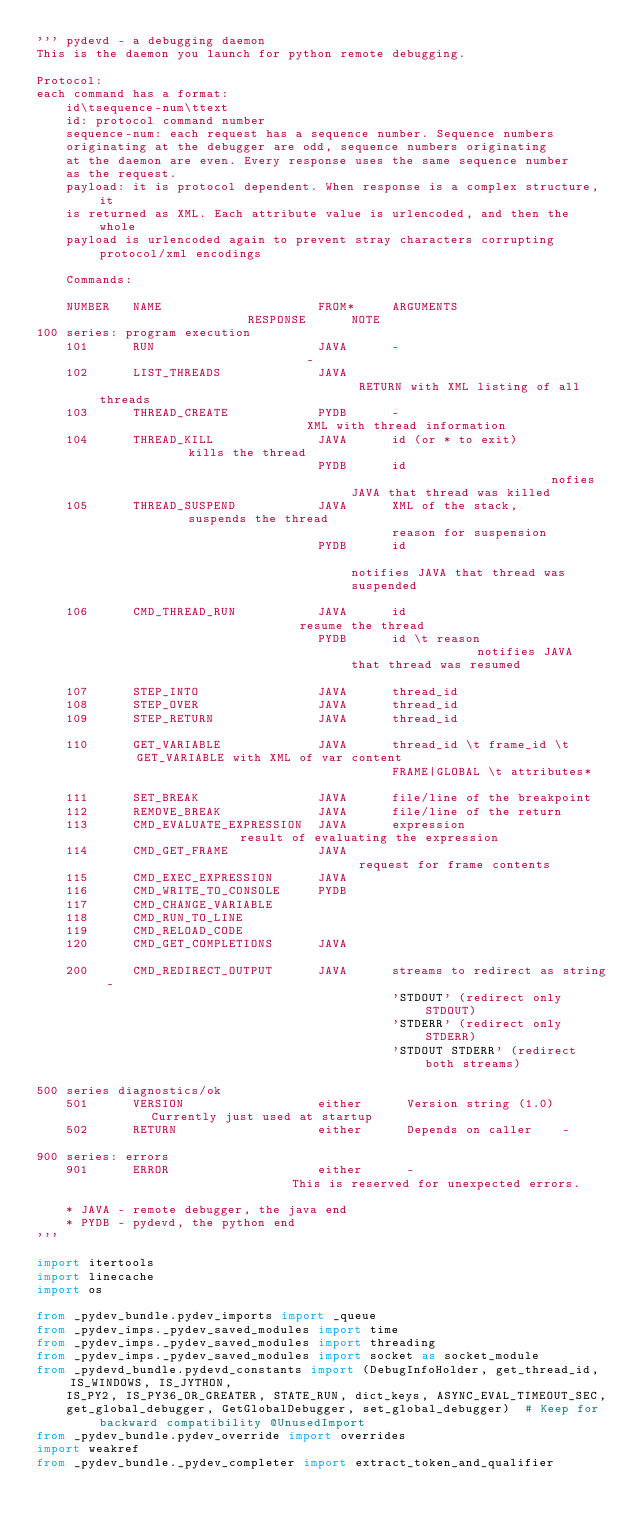<code> <loc_0><loc_0><loc_500><loc_500><_Python_>''' pydevd - a debugging daemon
This is the daemon you launch for python remote debugging.

Protocol:
each command has a format:
    id\tsequence-num\ttext
    id: protocol command number
    sequence-num: each request has a sequence number. Sequence numbers
    originating at the debugger are odd, sequence numbers originating
    at the daemon are even. Every response uses the same sequence number
    as the request.
    payload: it is protocol dependent. When response is a complex structure, it
    is returned as XML. Each attribute value is urlencoded, and then the whole
    payload is urlencoded again to prevent stray characters corrupting protocol/xml encodings

    Commands:

    NUMBER   NAME                     FROM*     ARGUMENTS                     RESPONSE      NOTE
100 series: program execution
    101      RUN                      JAVA      -                             -
    102      LIST_THREADS             JAVA                                    RETURN with XML listing of all threads
    103      THREAD_CREATE            PYDB      -                             XML with thread information
    104      THREAD_KILL              JAVA      id (or * to exit)             kills the thread
                                      PYDB      id                            nofies JAVA that thread was killed
    105      THREAD_SUSPEND           JAVA      XML of the stack,             suspends the thread
                                                reason for suspension
                                      PYDB      id                            notifies JAVA that thread was suspended

    106      CMD_THREAD_RUN           JAVA      id                            resume the thread
                                      PYDB      id \t reason                  notifies JAVA that thread was resumed

    107      STEP_INTO                JAVA      thread_id
    108      STEP_OVER                JAVA      thread_id
    109      STEP_RETURN              JAVA      thread_id

    110      GET_VARIABLE             JAVA      thread_id \t frame_id \t      GET_VARIABLE with XML of var content
                                                FRAME|GLOBAL \t attributes*

    111      SET_BREAK                JAVA      file/line of the breakpoint
    112      REMOVE_BREAK             JAVA      file/line of the return
    113      CMD_EVALUATE_EXPRESSION  JAVA      expression                    result of evaluating the expression
    114      CMD_GET_FRAME            JAVA                                    request for frame contents
    115      CMD_EXEC_EXPRESSION      JAVA
    116      CMD_WRITE_TO_CONSOLE     PYDB
    117      CMD_CHANGE_VARIABLE
    118      CMD_RUN_TO_LINE
    119      CMD_RELOAD_CODE
    120      CMD_GET_COMPLETIONS      JAVA

    200      CMD_REDIRECT_OUTPUT      JAVA      streams to redirect as string -
                                                'STDOUT' (redirect only STDOUT)
                                                'STDERR' (redirect only STDERR)
                                                'STDOUT STDERR' (redirect both streams)

500 series diagnostics/ok
    501      VERSION                  either      Version string (1.0)        Currently just used at startup
    502      RETURN                   either      Depends on caller    -

900 series: errors
    901      ERROR                    either      -                           This is reserved for unexpected errors.

    * JAVA - remote debugger, the java end
    * PYDB - pydevd, the python end
'''

import itertools
import linecache
import os

from _pydev_bundle.pydev_imports import _queue
from _pydev_imps._pydev_saved_modules import time
from _pydev_imps._pydev_saved_modules import threading
from _pydev_imps._pydev_saved_modules import socket as socket_module
from _pydevd_bundle.pydevd_constants import (DebugInfoHolder, get_thread_id, IS_WINDOWS, IS_JYTHON,
    IS_PY2, IS_PY36_OR_GREATER, STATE_RUN, dict_keys, ASYNC_EVAL_TIMEOUT_SEC,
    get_global_debugger, GetGlobalDebugger, set_global_debugger)  # Keep for backward compatibility @UnusedImport
from _pydev_bundle.pydev_override import overrides
import weakref
from _pydev_bundle._pydev_completer import extract_token_and_qualifier</code> 